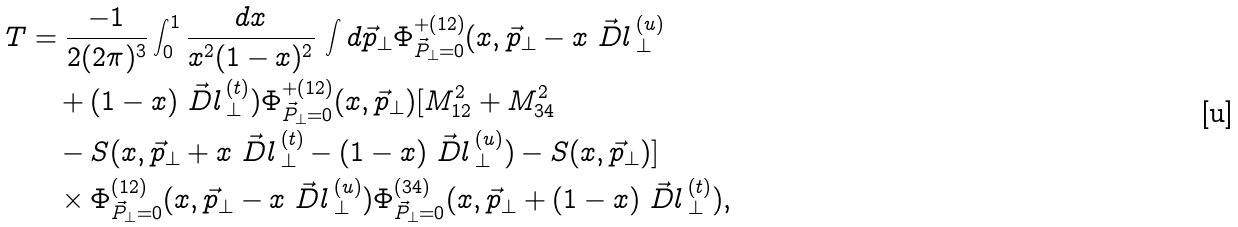Convert formula to latex. <formula><loc_0><loc_0><loc_500><loc_500>T & = \frac { - 1 } { 2 ( 2 \pi ) ^ { 3 } } \int _ { 0 } ^ { 1 } \frac { d x } { x ^ { 2 } ( 1 - x ) ^ { 2 } } \, \int d \vec { p } _ { \bot } \Phi _ { \vec { P } _ { \bot } = 0 } ^ { + { ( 1 2 ) } } ( x , \vec { p } _ { \bot } - x \vec { \ D l } { \, } _ { \bot } ^ { ( u ) } \\ & \quad + ( 1 - x ) \vec { \ D l } { \, } _ { \bot } ^ { ( t ) } ) \Phi _ { \vec { P } _ { \bot } = 0 } ^ { + { ( 1 2 ) } } ( x , \vec { p } _ { \bot } ) [ M _ { 1 2 } ^ { 2 } + M _ { 3 4 } ^ { 2 } \\ & \quad - S ( x , \vec { p } _ { \bot } + x \vec { \ D l } { \, } _ { \bot } ^ { ( t ) } - ( 1 - x ) \vec { \ D l } { \, } _ { \bot } ^ { ( u ) } ) - S ( x , \vec { p } _ { \bot } ) ] \\ & \quad \times \Phi _ { \vec { P } _ { \bot } = 0 } ^ { ( 1 2 ) } ( x , \vec { p } _ { \bot } - x \vec { \ D l } { \, } _ { \bot } ^ { ( u ) } ) \Phi _ { \vec { P } _ { \bot } = 0 } ^ { ( 3 4 ) } ( x , \vec { p } _ { \bot } + ( 1 - x ) \vec { \ D l } { \, } _ { \bot } ^ { ( t ) } ) ,</formula> 